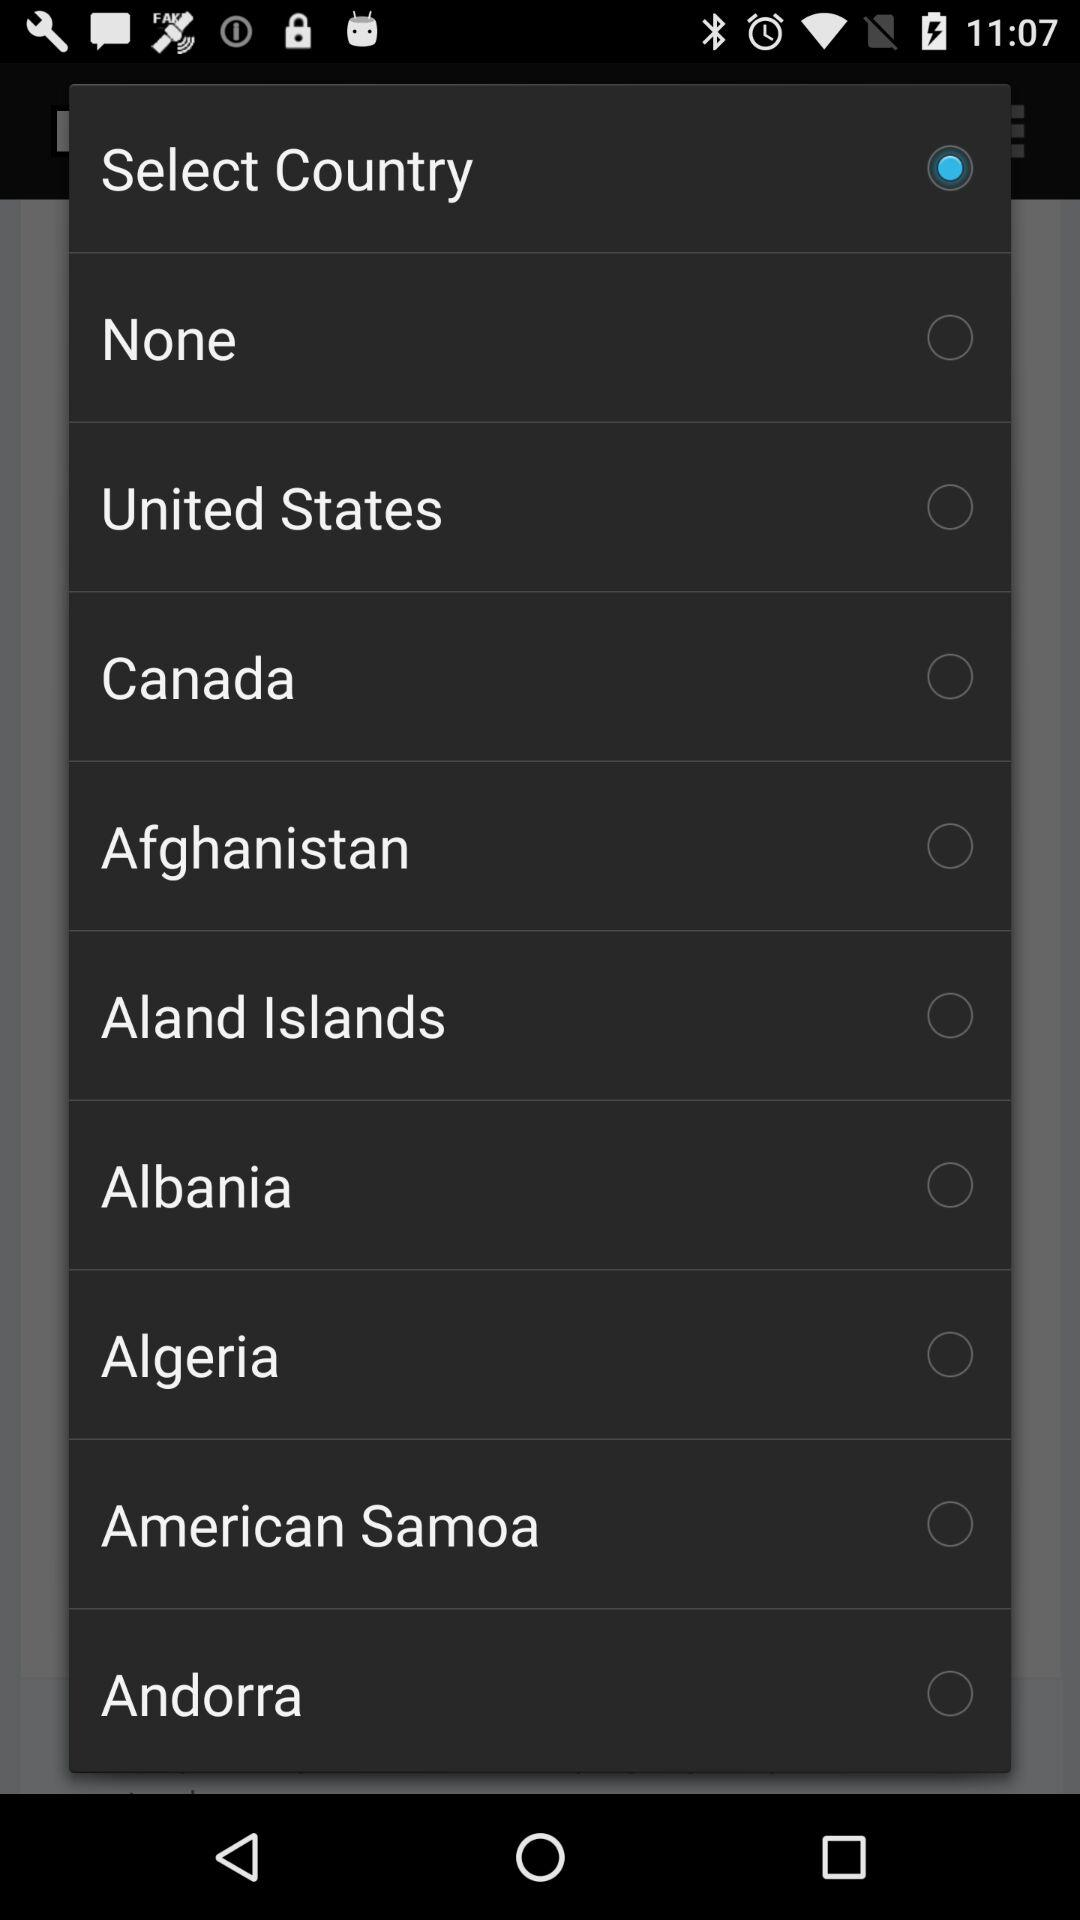Is "Canada" selected or not? It is not selected. 